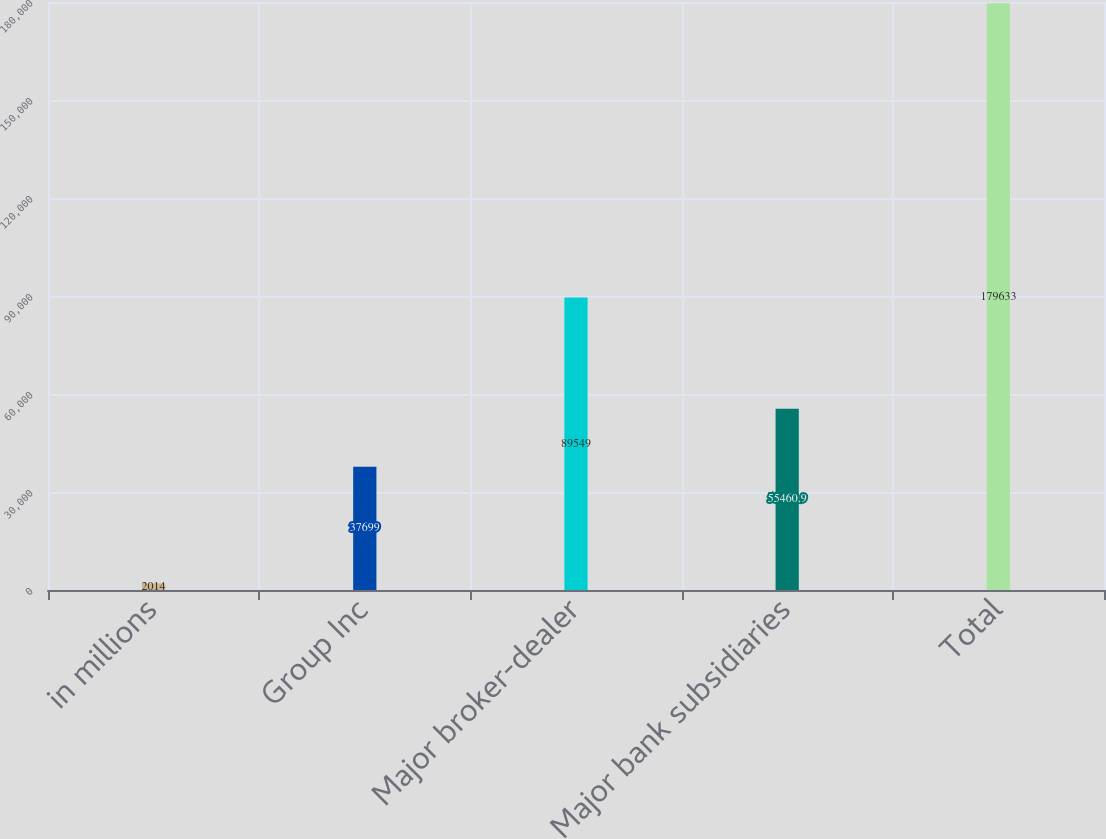<chart> <loc_0><loc_0><loc_500><loc_500><bar_chart><fcel>in millions<fcel>Group Inc<fcel>Major broker-dealer<fcel>Major bank subsidiaries<fcel>Total<nl><fcel>2014<fcel>37699<fcel>89549<fcel>55460.9<fcel>179633<nl></chart> 